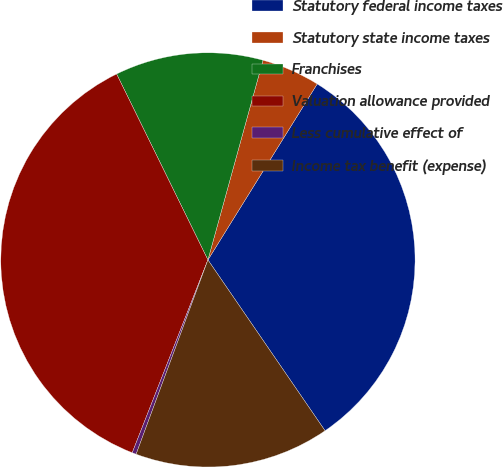Convert chart. <chart><loc_0><loc_0><loc_500><loc_500><pie_chart><fcel>Statutory federal income taxes<fcel>Statutory state income taxes<fcel>Franchises<fcel>Valuation allowance provided<fcel>Less cumulative effect of<fcel>Income tax benefit (expense)<nl><fcel>31.59%<fcel>4.56%<fcel>11.55%<fcel>36.78%<fcel>0.32%<fcel>15.2%<nl></chart> 